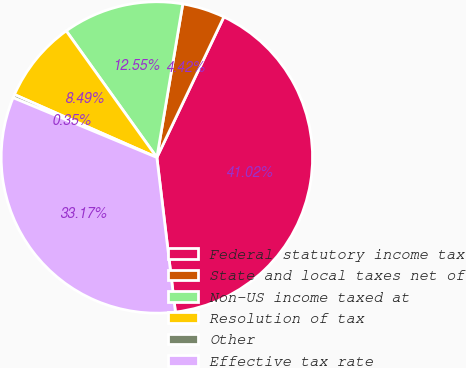Convert chart to OTSL. <chart><loc_0><loc_0><loc_500><loc_500><pie_chart><fcel>Federal statutory income tax<fcel>State and local taxes net of<fcel>Non-US income taxed at<fcel>Resolution of tax<fcel>Other<fcel>Effective tax rate<nl><fcel>41.02%<fcel>4.42%<fcel>12.55%<fcel>8.49%<fcel>0.35%<fcel>33.17%<nl></chart> 